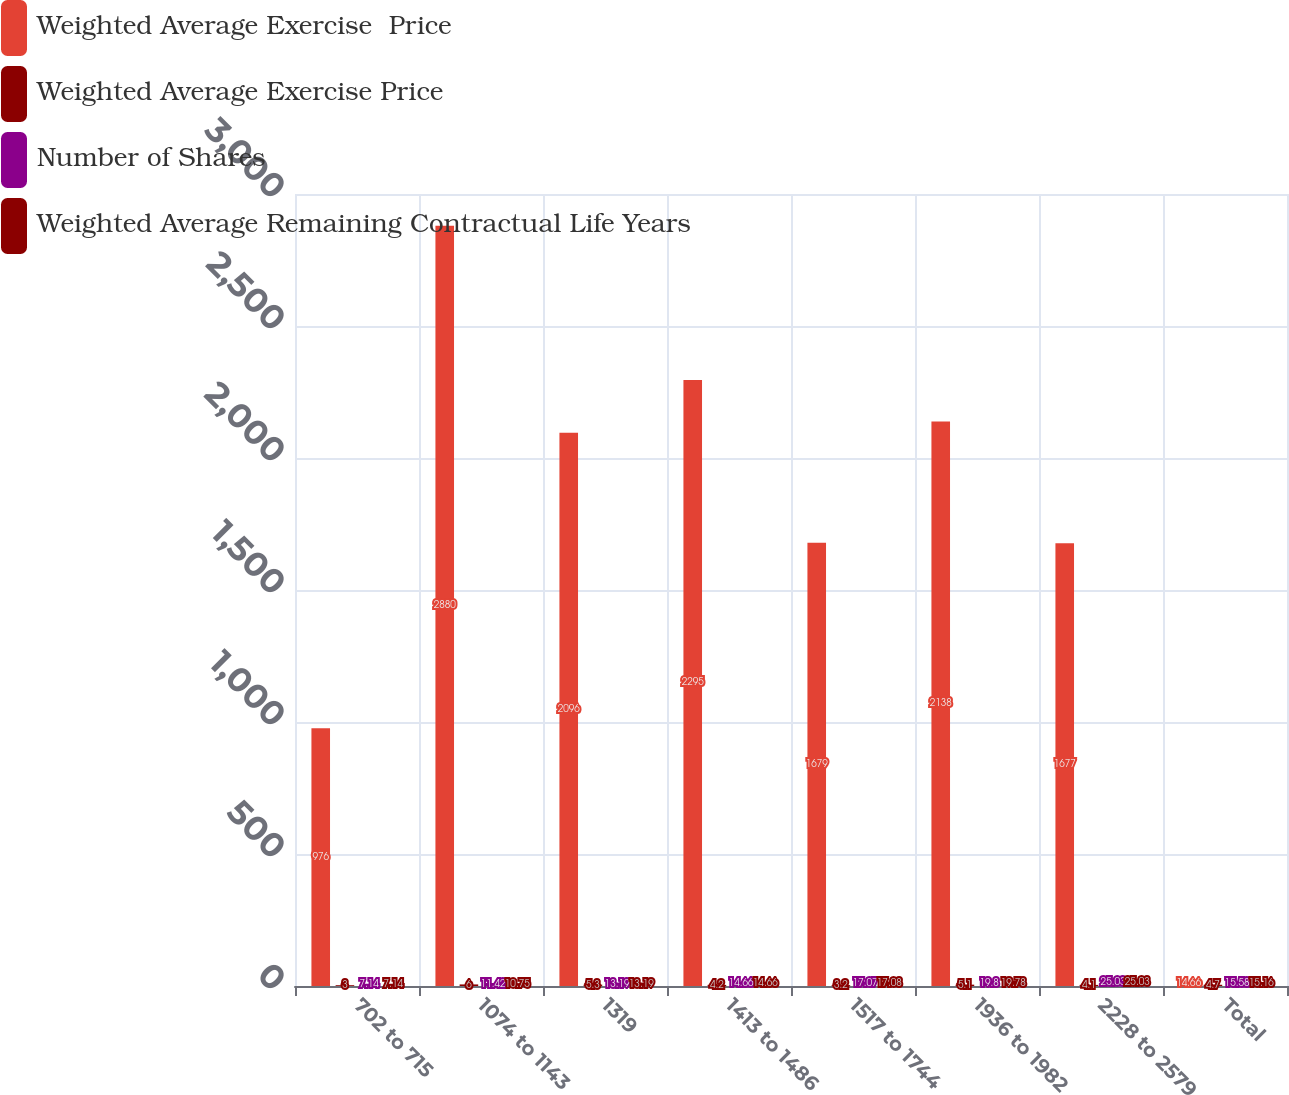Convert chart. <chart><loc_0><loc_0><loc_500><loc_500><stacked_bar_chart><ecel><fcel>702 to 715<fcel>1074 to 1143<fcel>1319<fcel>1413 to 1486<fcel>1517 to 1744<fcel>1936 to 1982<fcel>2228 to 2579<fcel>Total<nl><fcel>Weighted Average Exercise  Price<fcel>976<fcel>2880<fcel>2096<fcel>2295<fcel>1679<fcel>2138<fcel>1677<fcel>14.66<nl><fcel>Weighted Average Exercise Price<fcel>3<fcel>6<fcel>5.3<fcel>4.2<fcel>3.2<fcel>5.1<fcel>4.1<fcel>4.7<nl><fcel>Number of Shares<fcel>7.14<fcel>11.42<fcel>13.19<fcel>14.66<fcel>17.07<fcel>19.8<fcel>25.03<fcel>15.58<nl><fcel>Weighted Average Remaining Contractual Life Years<fcel>7.14<fcel>10.75<fcel>13.19<fcel>14.66<fcel>17.08<fcel>19.78<fcel>25.03<fcel>15.16<nl></chart> 